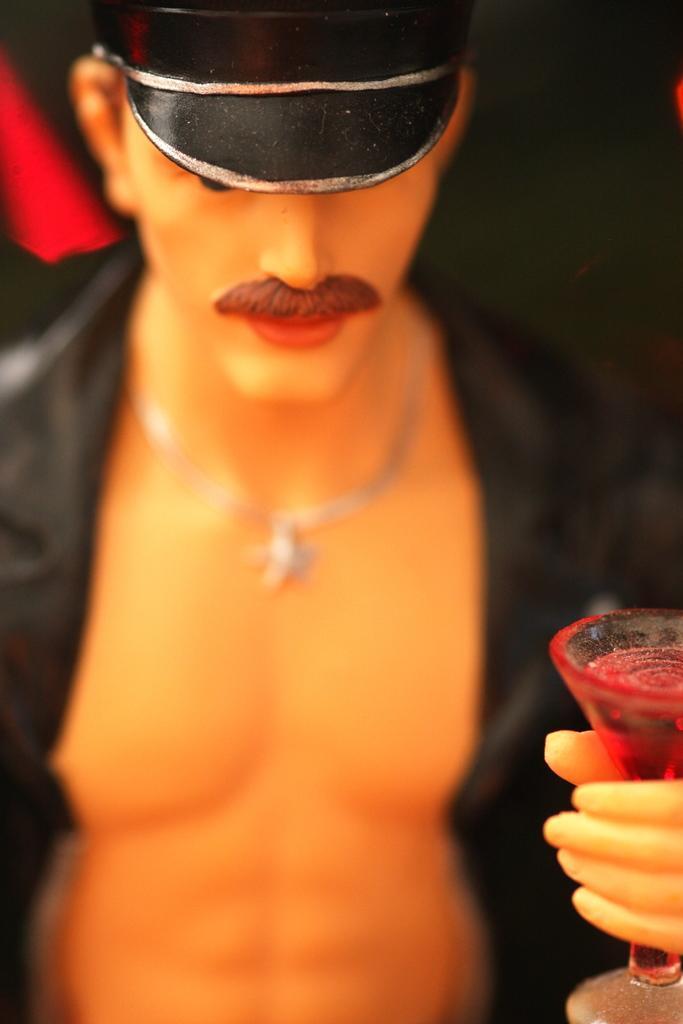In one or two sentences, can you explain what this image depicts? In this image, we can see a statue holding a glass and there is a hat on the head of the statue. 